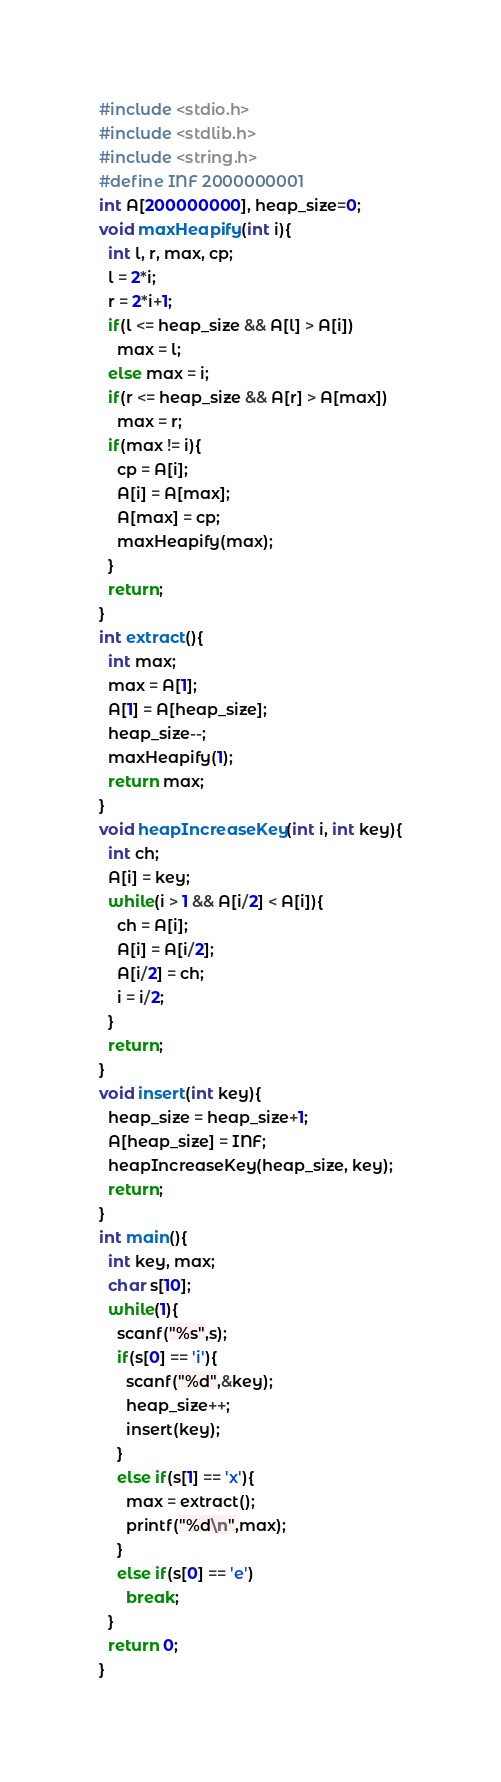<code> <loc_0><loc_0><loc_500><loc_500><_C_>#include <stdio.h>
#include <stdlib.h>
#include <string.h>
#define INF 2000000001
int A[200000000], heap_size=0;
void maxHeapify(int i){
  int l, r, max, cp;
  l = 2*i;
  r = 2*i+1;
  if(l <= heap_size && A[l] > A[i])
    max = l;
  else max = i;
  if(r <= heap_size && A[r] > A[max])
    max = r;
  if(max != i){
    cp = A[i];
    A[i] = A[max];
    A[max] = cp;
    maxHeapify(max);
  }
  return;
}
int extract(){
  int max;
  max = A[1];
  A[1] = A[heap_size];
  heap_size--;
  maxHeapify(1);
  return max;
}
void heapIncreaseKey(int i, int key){
  int ch;
  A[i] = key;
  while(i > 1 && A[i/2] < A[i]){
    ch = A[i];
    A[i] = A[i/2];
    A[i/2] = ch;
    i = i/2;
  }
  return;
}
void insert(int key){
  heap_size = heap_size+1;
  A[heap_size] = INF;
  heapIncreaseKey(heap_size, key);
  return;
}
int main(){
  int key, max;
  char s[10];
  while(1){
    scanf("%s",s);
    if(s[0] == 'i'){
      scanf("%d",&key);
      heap_size++;
      insert(key);
    }
    else if(s[1] == 'x'){
      max = extract();
      printf("%d\n",max);
    }
    else if(s[0] == 'e')
      break;
  }
  return 0;
}</code> 